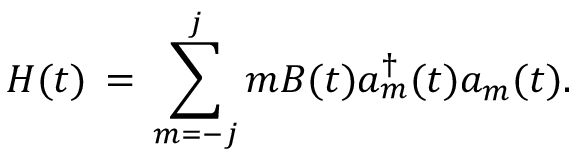<formula> <loc_0><loc_0><loc_500><loc_500>H ( t ) \, = \, \sum _ { m = - j } ^ { j } m B ( t ) a _ { m } ^ { \dagger } ( t ) a _ { m } ( t ) .</formula> 